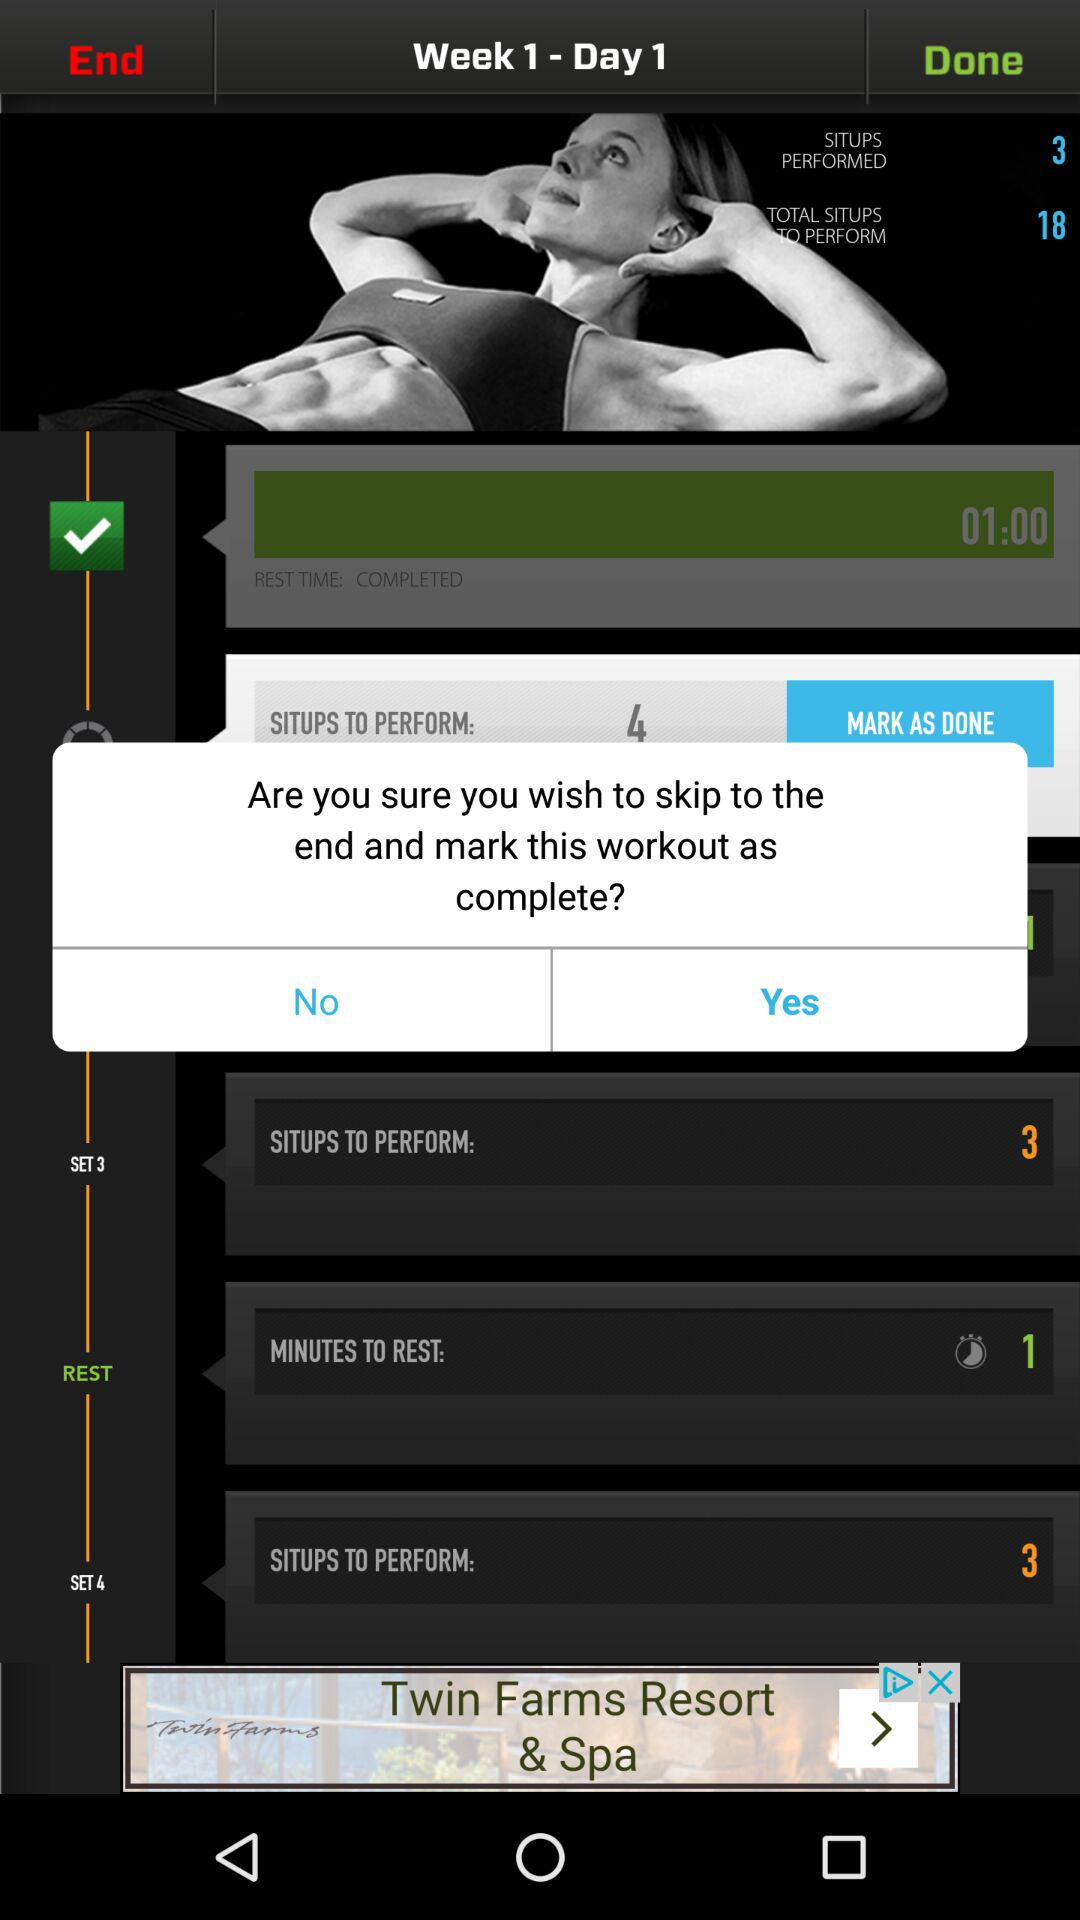How many more situps do I need to perform?
Answer the question using a single word or phrase. 15 